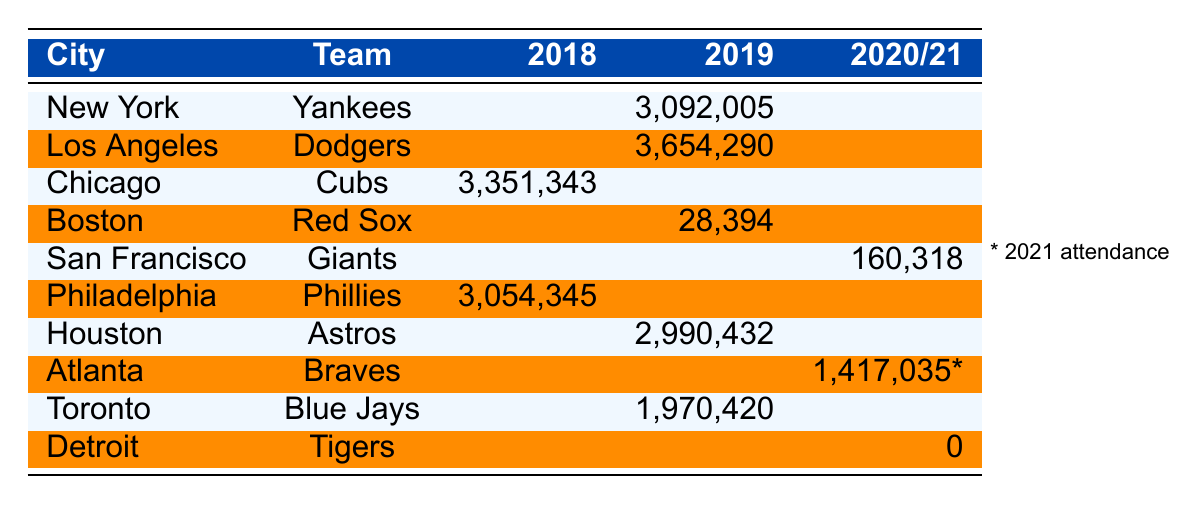What is the attendance for the New York Yankees in 2019? The table shows that the attendance for the New York Yankees in 2019 is listed as 3,092,005.
Answer: 3,092,005 Which team had the highest attendance in 2019? According to the table, the team with the highest attendance in 2019 is the Los Angeles Dodgers with 3,654,290.
Answer: Los Angeles Dodgers What was the attendance of the Boston Red Sox in 2019? The table indicates that the attendance for the Boston Red Sox in 2019 is 28,394.
Answer: 28,394 Which team had lower attendance in 2019, the Boston Red Sox or the Houston Astros? The Boston Red Sox's attendance was 28,394 and the Houston Astros' was 2,990,432. Since 28,394 is less than 2,990,432, the Boston Red Sox had lower attendance.
Answer: Boston Red Sox What is the combined attendance for the Chicago Cubs in 2018 and the Los Angeles Dodgers in 2019? The attendance for the Chicago Cubs in 2018 is 3,351,343 and for the Los Angeles Dodgers in 2019 is 3,654,290. Combining these gives 3,351,343 + 3,654,290 = 6,005,633.
Answer: 6,005,633 What is the average attendance of all teams listed for the year 2019? For 2019, the teams and their attendances are: Yankees (3,092,005), Dodgers (3,654,290), Astros (2,990,432), and Blue Jays (1,970,420). The average is calculated as (3,092,005 + 3,654,290 + 2,990,432 + 1,970,420) / 4 = 2,926,036.75.
Answer: 2,926,036.75 Is the attendance for the Detroit Tigers in 2020 recorded? The attendance for the Detroit Tigers in 2020 is recorded as 0, meaning no attendance was documented.
Answer: Yes, it is recorded as 0 Which city had the lowest recorded attendance across the years shown? The lowest recorded attendance is from Boston in 2019 with 28,394. For other events, the lowest record is from Detroit in 2020 with 0. Therefore, Detroit had the lowest overall recorded attendance.
Answer: Detroit How much did the attendance of the Philadelphia Phillies in 2018 exceed the attendance of the Boston Red Sox in 2019? The Philadelphia Phillies had an attendance of 3,054,345 in 2018 while the Boston Red Sox had 28,394 in 2019. The difference is 3,054,345 - 28,394 = 3,025,951.
Answer: 3,025,951 Which city had the highest attendance in 2021, according to the table? The table shows Atlanta Braves had an attendance of 1,417,035 in 2021, which is the only attendance listed for that year. Therefore, Atlanta has the highest attendance.
Answer: Atlanta 